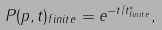<formula> <loc_0><loc_0><loc_500><loc_500>P ( p , t ) _ { f i n i t e } = e ^ { - t / t ^ { * } _ { f i n i t e } } ,</formula> 